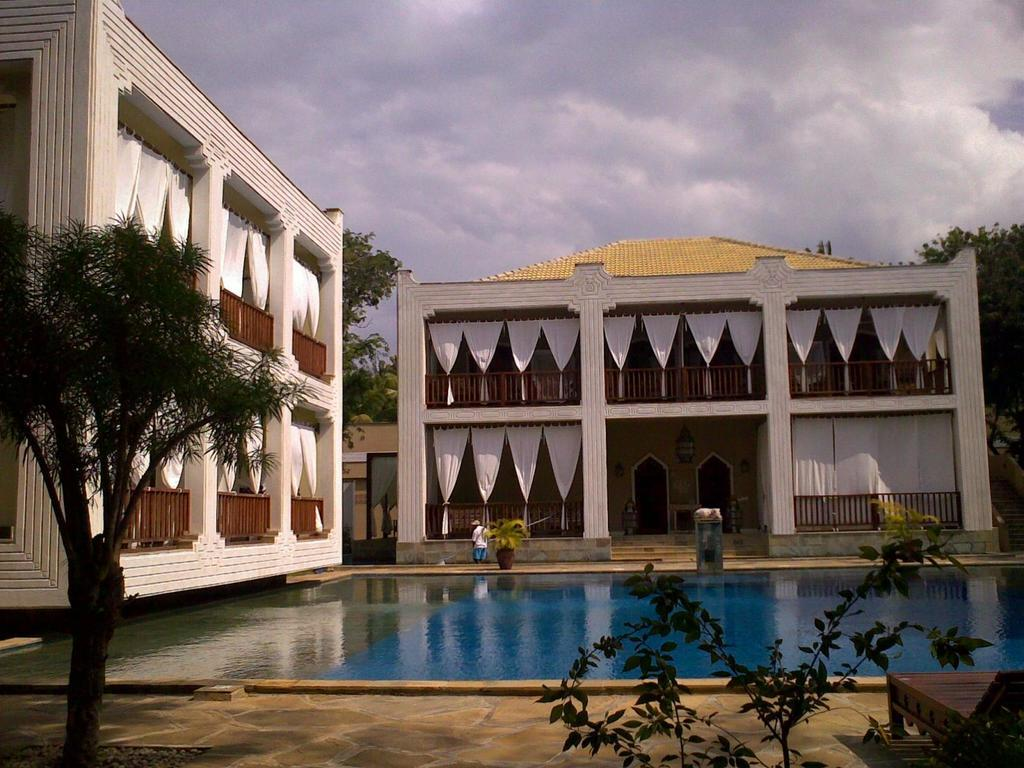What is the main subject in the middle of the image? There is a swimming pool in the middle of the image. What can be seen in the background of the image? There are buildings and trees in the background of the image. Is there anyone visible in the image? Yes, there is a person in the background of the image. What type of furniture is present near the swimming pool? There is a pool chair in the bottom right-hand side of the image. Can you see any snails crawling on the pool chair in the image? There are no snails visible in the image. What type of wool is used to make the buildings in the background? The buildings in the background are not made of wool; they are likely constructed with traditional building materials such as brick, concrete, or wood. 